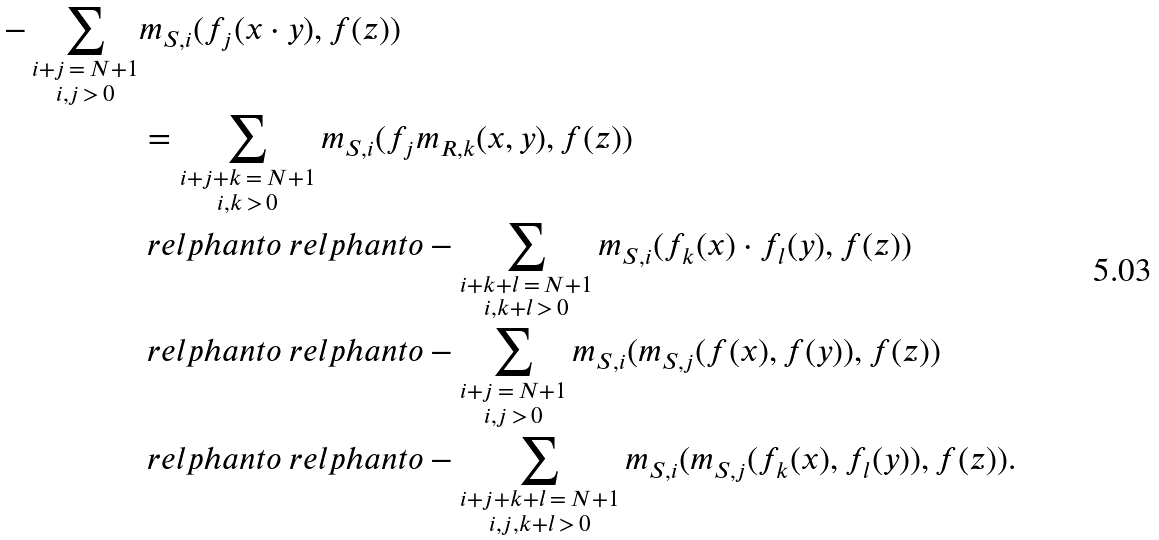Convert formula to latex. <formula><loc_0><loc_0><loc_500><loc_500>- \sum _ { \substack { i + j \, = \, N + 1 \\ i , j \, > \, 0 } } & m _ { S , i } ( f _ { j } ( x \cdot y ) , f ( z ) ) \\ & = \sum _ { \substack { i + j + k \, = \, N + 1 \\ i , k \, > \, 0 } } m _ { S , i } ( f _ { j } m _ { R , k } ( x , y ) , f ( z ) ) \\ & \ r e l p h a n t o \ r e l p h a n t o - \sum _ { \substack { i + k + l \, = \, N + 1 \\ i , k + l \, > \, 0 } } m _ { S , i } ( f _ { k } ( x ) \cdot f _ { l } ( y ) , f ( z ) ) \\ & \ r e l p h a n t o \ r e l p h a n t o - \sum _ { \substack { i + j \, = \, N + 1 \\ i , j \, > \, 0 } } m _ { S , i } ( m _ { S , j } ( f ( x ) , f ( y ) ) , f ( z ) ) \\ & \ r e l p h a n t o \ r e l p h a n t o - \sum _ { \substack { i + j + k + l \, = \, N + 1 \\ i , j , k + l \, > \, 0 } } m _ { S , i } ( m _ { S , j } ( f _ { k } ( x ) , f _ { l } ( y ) ) , f ( z ) ) .</formula> 